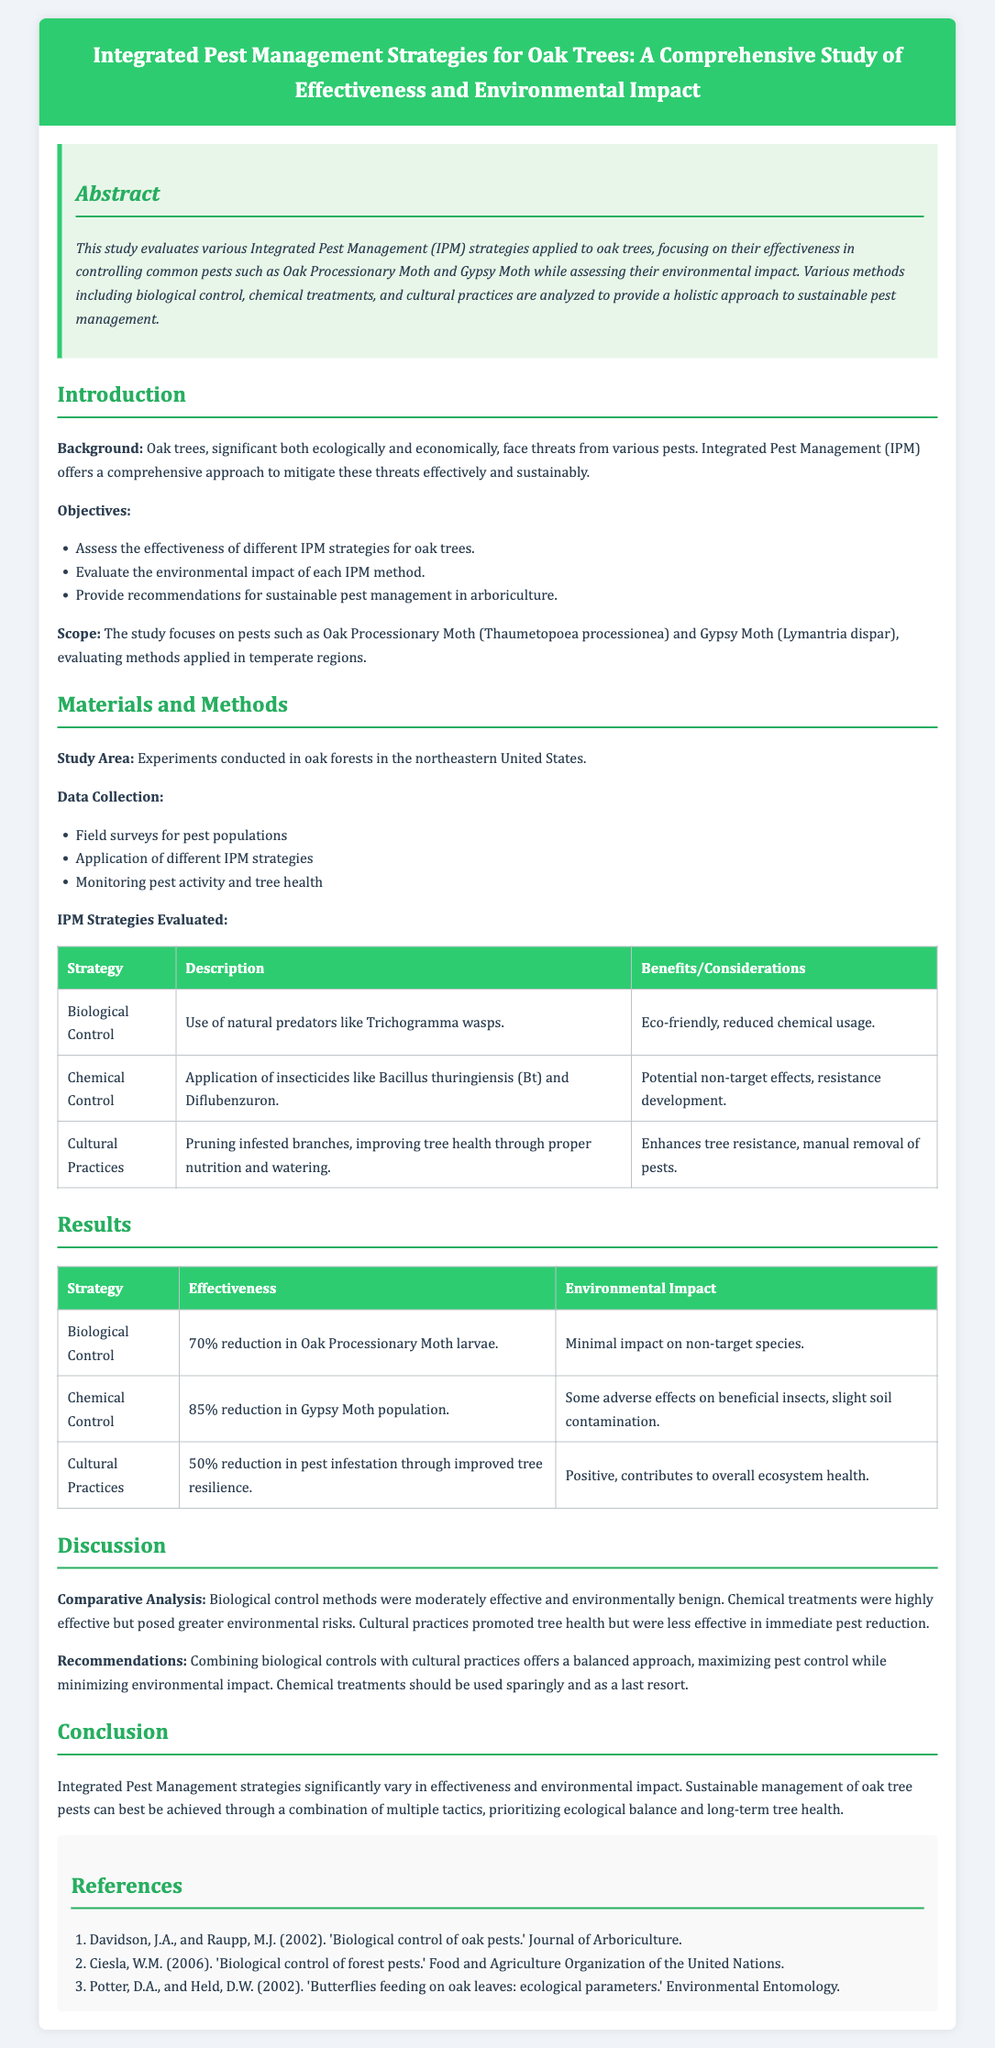What is the main focus of the study? The study evaluates various Integrated Pest Management (IPM) strategies applied to oak trees, focusing on their effectiveness in controlling common pests.
Answer: Effective pest control What pests are specifically evaluated in the study? The pests mentioned are Oak Processionary Moth and Gypsy Moth, specifically evaluated in the study.
Answer: Oak Processionary Moth and Gypsy Moth How effective was the biological control strategy? The biological control strategy led to a 70% reduction in Oak Processionary Moth larvae, which indicates its effectiveness.
Answer: 70% reduction What is one benefit of using biological control? The benefit of using biological control is that it is eco-friendly and reduces chemical usage.
Answer: Eco-friendly What environmental impact was observed with chemical control? The use of chemical control resulted in some adverse effects on beneficial insects and slight soil contamination.
Answer: Adverse effects Which IPM strategy had the highest effectiveness? The strategy with the highest effectiveness was chemical control, which had an 85% reduction in Gypsy Moth population.
Answer: 85% reduction What recommendation does the study provide regarding pest management? The study recommends combining biological controls with cultural practices for a balanced approach.
Answer: Combine biological controls with cultural practices What area was the study conducted in? The experiments were conducted in oak forests in the northeastern United States.
Answer: Northeastern United States 